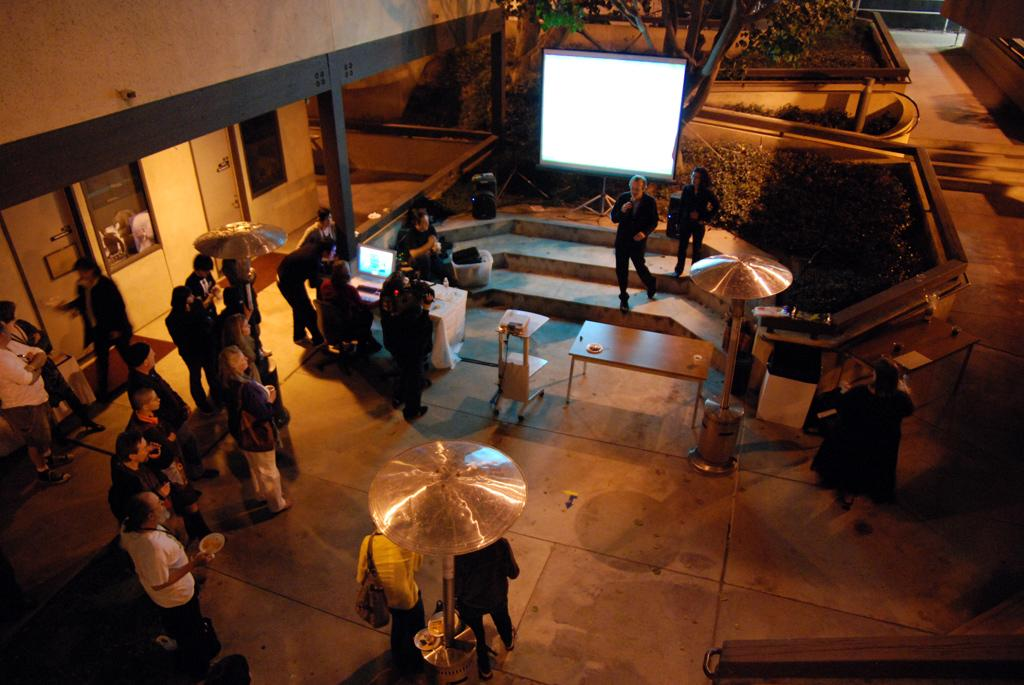How many people are in the image? There is a group of people in the image, but the exact number is not specified. What are the people in the image doing? The group of people are standing. What object is present in the image that is typically used for presentations or displays? There is a projector screen in the image. What type of worm can be seen crawling on the projector screen in the image? There is no worm present on the projector screen in the image. 